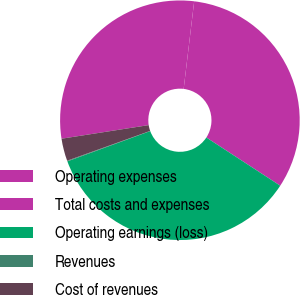<chart> <loc_0><loc_0><loc_500><loc_500><pie_chart><fcel>Operating expenses<fcel>Total costs and expenses<fcel>Operating earnings (loss)<fcel>Revenues<fcel>Cost of revenues<nl><fcel>29.37%<fcel>32.3%<fcel>35.23%<fcel>0.09%<fcel>3.02%<nl></chart> 